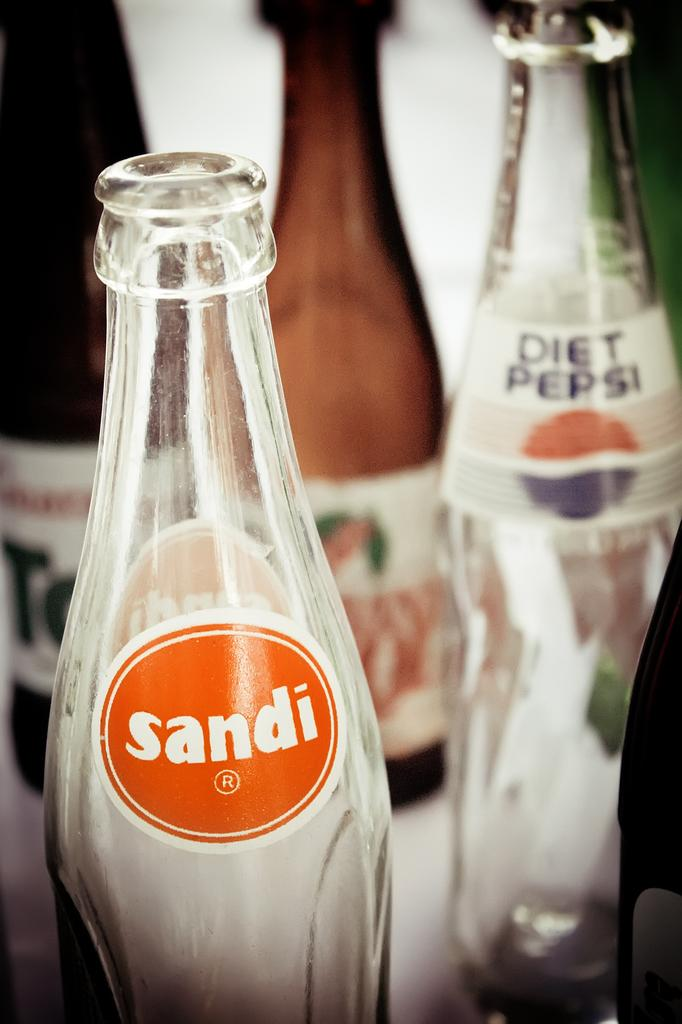How many brown bottles are in the image? There are two brown bottles in the image. How many white glass bottles are in the image? There are two white glass bottles in the image. What is on the bottles that can be seen in the image? The bottles have stickers with text on them. Is there a notebook present in the image? There is no mention of a notebook in the provided facts, so it cannot be determined if one is present in the image. 